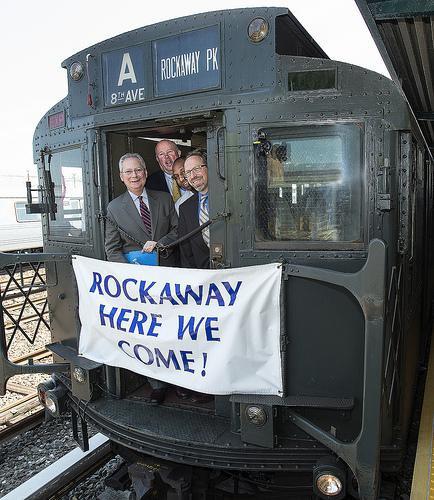Question: what is written in the banner?
Choices:
A. Rockaway or bust.
B. Cheer louder.
C. Rockaway here we come.
D. We love you rockaway.
Answer with the letter. Answer: C Question: who is in the train?
Choices:
A. Woman.
B. Girl.
C. Men.
D. Boy.
Answer with the letter. Answer: C Question: how many men in the train?
Choices:
A. Eight.
B. Four.
C. More than twenty.
D. Fifteen.
Answer with the letter. Answer: B Question: where are the men?
Choices:
A. On a bus.
B. Around a table.
C. On a bench.
D. In the train.
Answer with the letter. Answer: D Question: what is the color of the train?
Choices:
A. Green.
B. Blue.
C. Black.
D. Silver.
Answer with the letter. Answer: A Question: what is the color of the banner?
Choices:
A. Blue and white.
B. Red and gold.
C. Black and blue.
D. Blue and silver.
Answer with the letter. Answer: A 